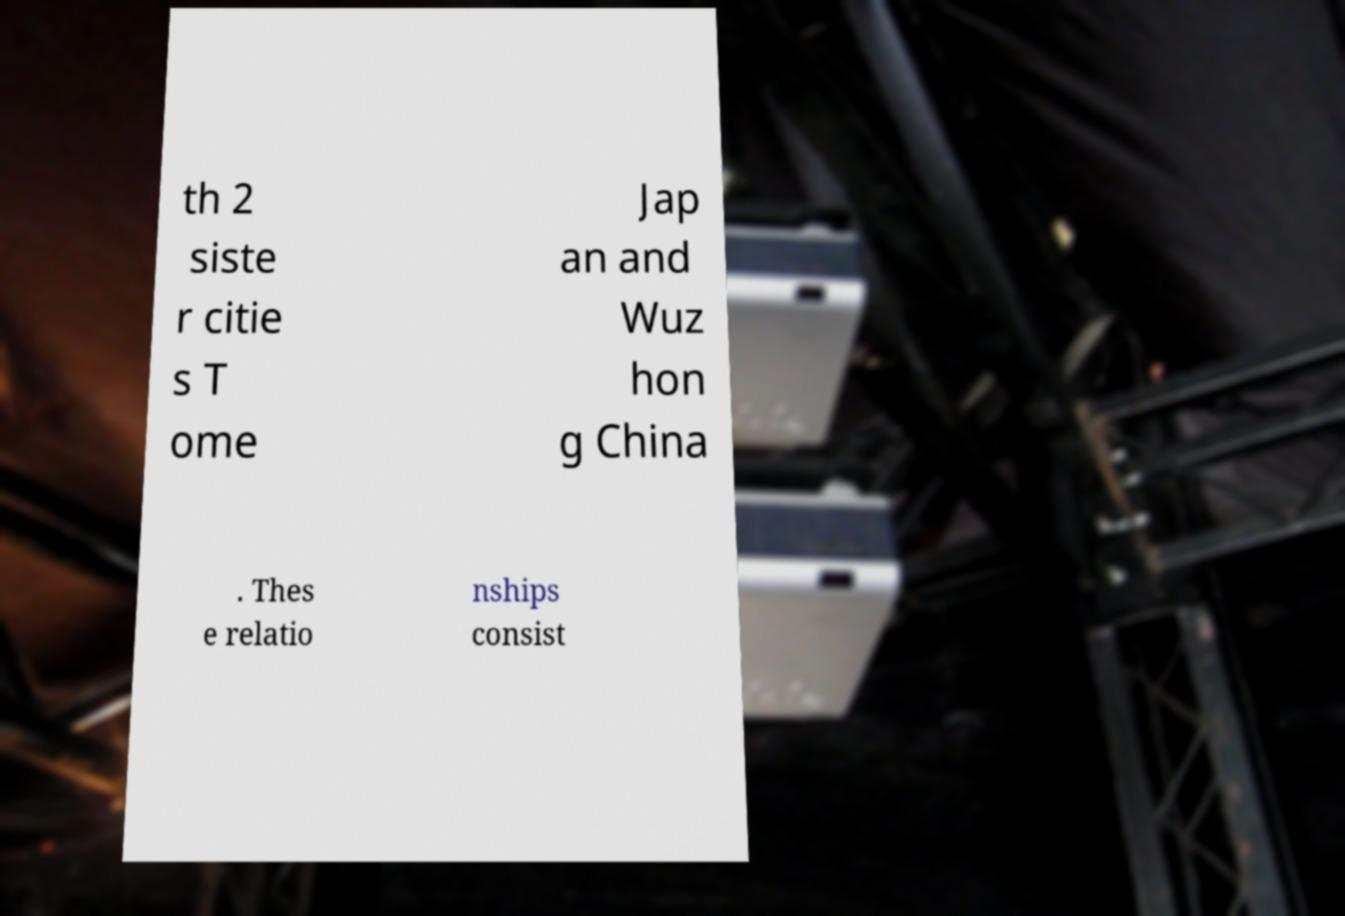Could you extract and type out the text from this image? th 2 siste r citie s T ome Jap an and Wuz hon g China . Thes e relatio nships consist 